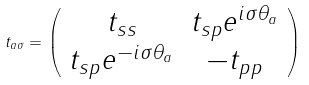<formula> <loc_0><loc_0><loc_500><loc_500>t _ { a \sigma } = \left ( \begin{array} { c c } t _ { s s } & t _ { s p } e ^ { i \sigma \theta _ { a } } \\ t _ { s p } e ^ { - i \sigma \theta _ { a } } & - t _ { p p } \end{array} \right )</formula> 